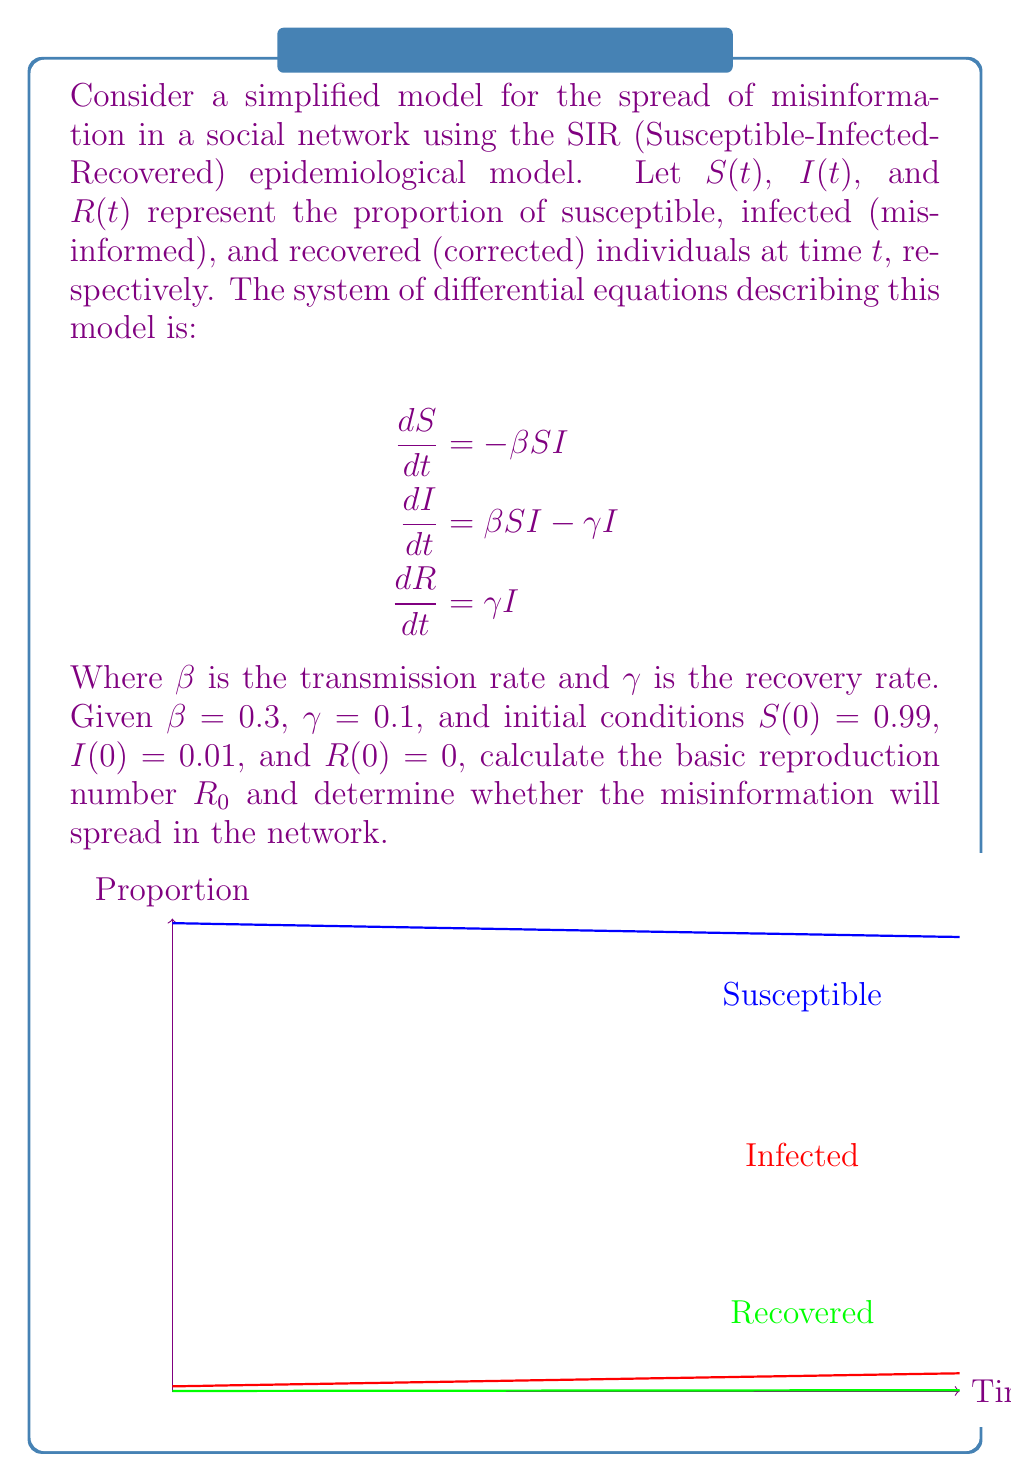Teach me how to tackle this problem. To solve this problem, we'll follow these steps:

1) Calculate the basic reproduction number $R_0$:
   The basic reproduction number $R_0$ is defined as the average number of secondary infections caused by one infected individual in a completely susceptible population. For the SIR model, $R_0$ is given by:

   $$R_0 = \frac{\beta}{\gamma}$$

   Substituting the given values:

   $$R_0 = \frac{0.3}{0.1} = 3$$

2) Interpret $R_0$:
   - If $R_0 > 1$, the misinformation will spread in the network.
   - If $R_0 < 1$, the misinformation will die out.
   - If $R_0 = 1$, the misinformation will persist but not spread.

3) In this case, $R_0 = 3 > 1$, which means the misinformation will spread in the network.

4) To further understand the dynamics, we can look at the peak of the infection:
   The maximum proportion of infected individuals occurs when $\frac{dI}{dt} = 0$:

   $$\beta SI - \gamma I = 0$$
   $$S = \frac{\gamma}{\beta} = \frac{1}{R_0} = \frac{1}{3}$$

   This means the infection will peak when the susceptible population drops to 1/3 of its initial value.

5) The final size of the epidemic (total proportion who become infected) can be estimated using the final size equation:

   $$\ln(S_{\infty}) = R_0(S_{\infty} - 1)$$

   Where $S_{\infty}$ is the final proportion of susceptible individuals. This equation doesn't have a closed-form solution but can be solved numerically.

From a data science perspective, this model provides a framework for analyzing the spread of misinformation in large datasets. Machine learning techniques could be used to estimate the parameters $\beta$ and $\gamma$ from real-world data, allowing for more accurate predictions of misinformation spread in specific networks or populations.
Answer: $R_0 = 3$; misinformation will spread. 